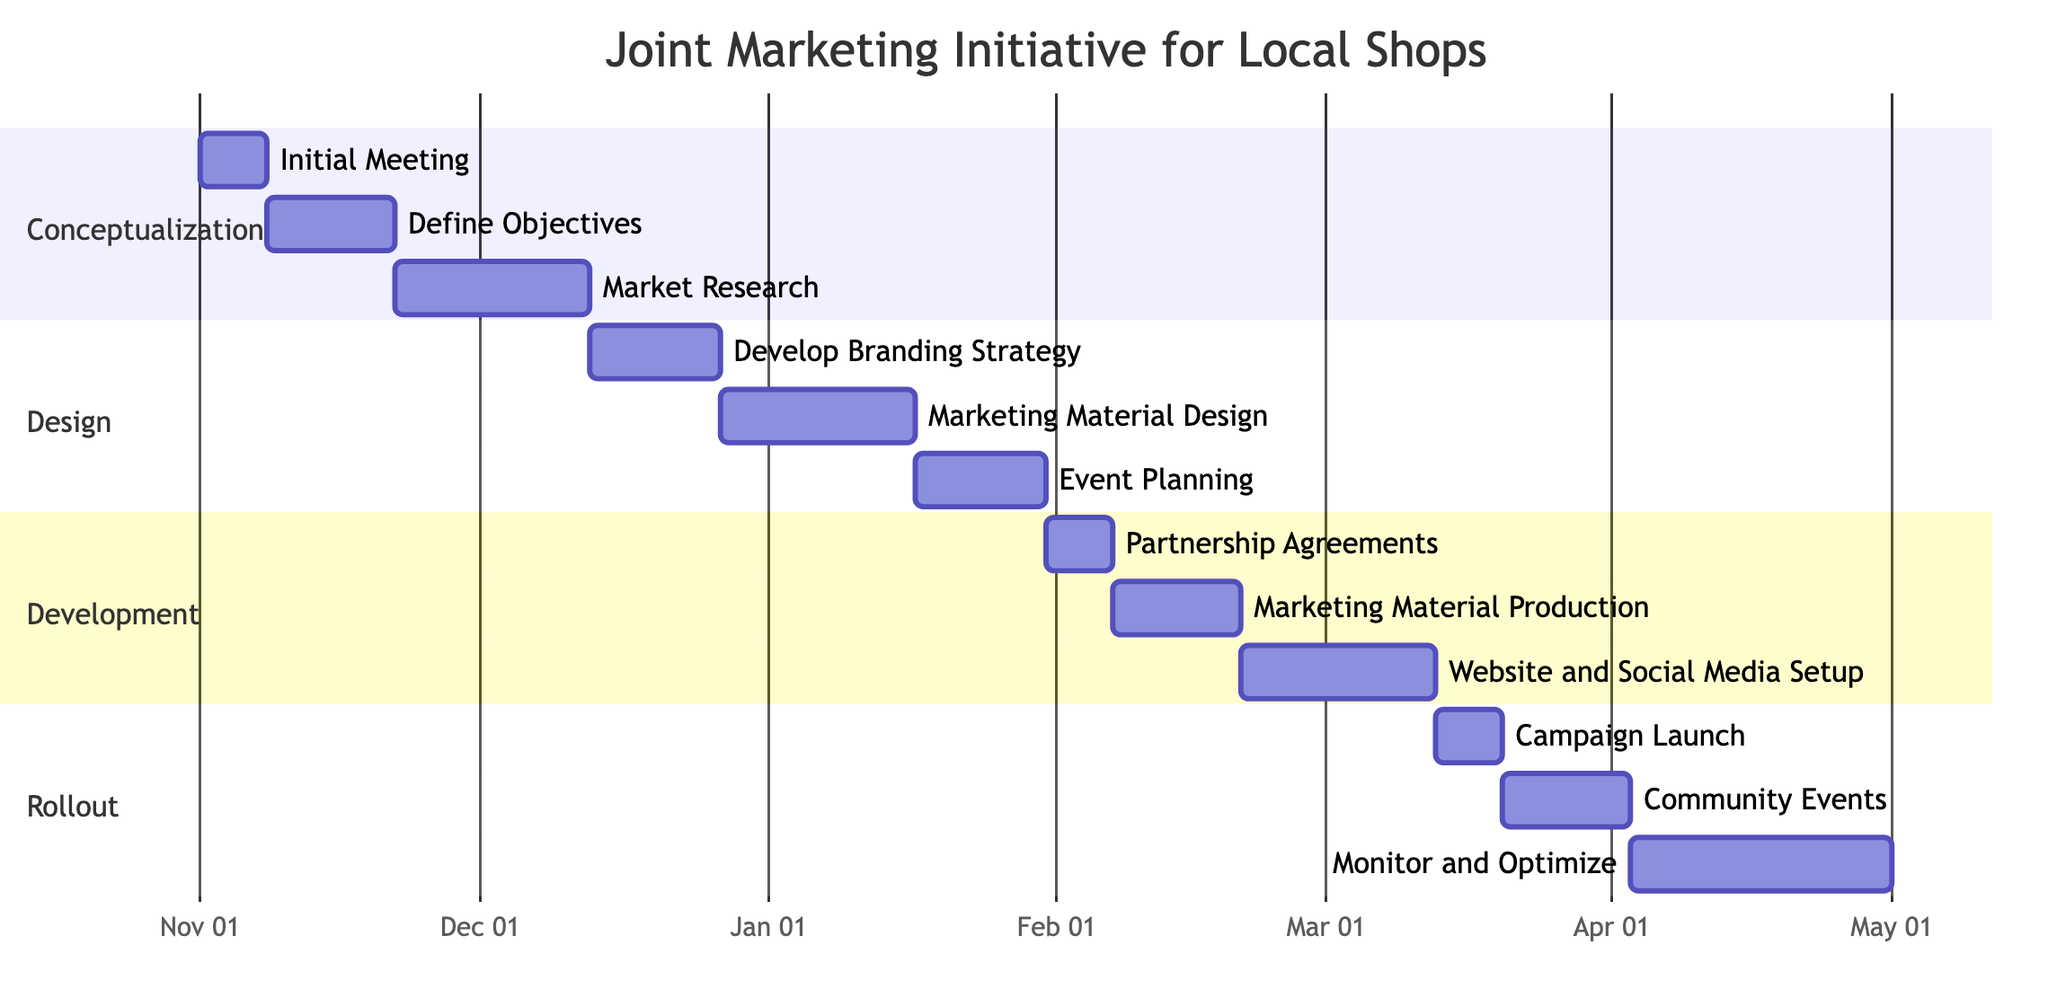What is the duration of the "Define Objectives" task? The "Define Objectives" task has a duration of 2 weeks as indicated directly under the task name in the Gantt chart.
Answer: 2 weeks How many tasks are in the "Design" phase? The "Design" phase consists of three tasks: "Develop Branding Strategy," "Marketing Material Design," and "Event Planning." This can be counted directly from the diagram section for Design.
Answer: 3 When does the "Community Events" task start? The "Community Events" task starts right after the "Campaign Launch" task, which ends on March 19, 2024. Therefore, the "Community Events" task starts on March 20, 2024.
Answer: March 20, 2024 What task comes immediately after "Market Research"? The task that comes immediately after "Market Research" is "Develop Branding Strategy." This can be confirmed by looking at the flow of tasks in the Gantt chart.
Answer: Develop Branding Strategy How long is the total duration of the "Rollout" phase? The "Rollout" phase has three tasks: "Campaign Launch" (1 week), "Community Events" (2 weeks), and "Monitor and Optimize" (4 weeks). The total duration is calculated by summing these durations: 1 + 2 + 4 = 7 weeks.
Answer: 7 weeks What is the start date of the "Website and Social Media Setup" task? The "Website and Social Media Setup" task begins after the "Marketing Material Production" task, which ends on February 20, 2024. Thus, it starts on February 21, 2024.
Answer: February 21, 2024 Which task requires the longest duration in the "Development" phase? In the "Development" phase, the "Website and Social Media Setup" task has the longest duration of 3 weeks, which is directly shown next to the task name.
Answer: Website and Social Media Setup How many weeks does "Monitor and Optimize" last? The "Monitor and Optimize" task lasts for 4 weeks, as indicated next to the task in the Gantt chart.
Answer: 4 weeks 